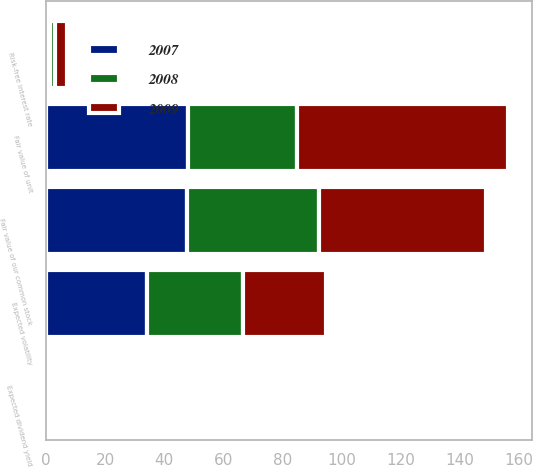Convert chart to OTSL. <chart><loc_0><loc_0><loc_500><loc_500><stacked_bar_chart><ecel><fcel>Fair value of our common stock<fcel>Fair value of unit<fcel>Expected volatility<fcel>Risk-free interest rate<fcel>Expected dividend yield<nl><fcel>2007<fcel>47.63<fcel>48.22<fcel>34.3<fcel>1.2<fcel>0<nl><fcel>2008<fcel>44.62<fcel>36.91<fcel>32.4<fcel>2<fcel>0<nl><fcel>2009<fcel>56.56<fcel>71.41<fcel>28.1<fcel>4<fcel>0<nl></chart> 